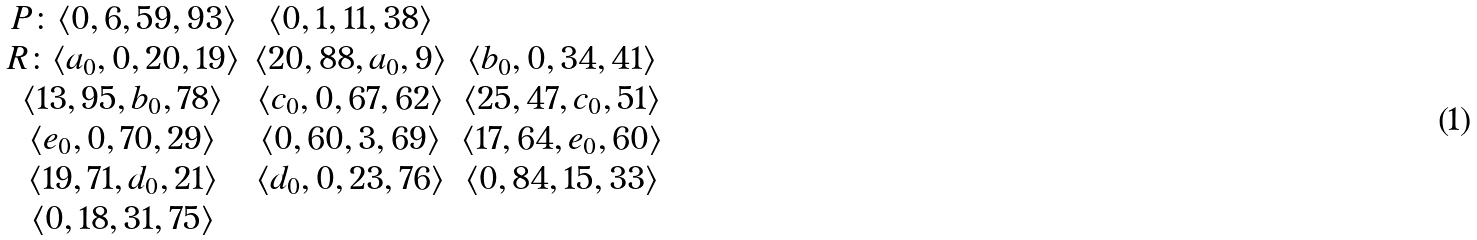Convert formula to latex. <formula><loc_0><loc_0><loc_500><loc_500>\begin{array} { c c c } P \colon \langle 0 , 6 , 5 9 , 9 3 \rangle & \langle 0 , 1 , 1 1 , 3 8 \rangle \\ R \colon \langle a _ { 0 } , 0 , 2 0 , 1 9 \rangle & \langle 2 0 , 8 8 , a _ { 0 } , 9 \rangle & \langle b _ { 0 } , 0 , 3 4 , 4 1 \rangle \\ \langle 1 3 , 9 5 , b _ { 0 } , 7 8 \rangle & \langle c _ { 0 } , 0 , 6 7 , 6 2 \rangle & \langle 2 5 , 4 7 , c _ { 0 } , 5 1 \rangle \\ \langle e _ { 0 } , 0 , 7 0 , 2 9 \rangle & \langle 0 , 6 0 , 3 , 6 9 \rangle & \langle 1 7 , 6 4 , e _ { 0 } , 6 0 \rangle \\ \langle 1 9 , 7 1 , d _ { 0 } , 2 1 \rangle & \langle d _ { 0 } , 0 , 2 3 , 7 6 \rangle & \langle 0 , 8 4 , 1 5 , 3 3 \rangle \\ \langle 0 , 1 8 , 3 1 , 7 5 \rangle \\ \end{array}</formula> 